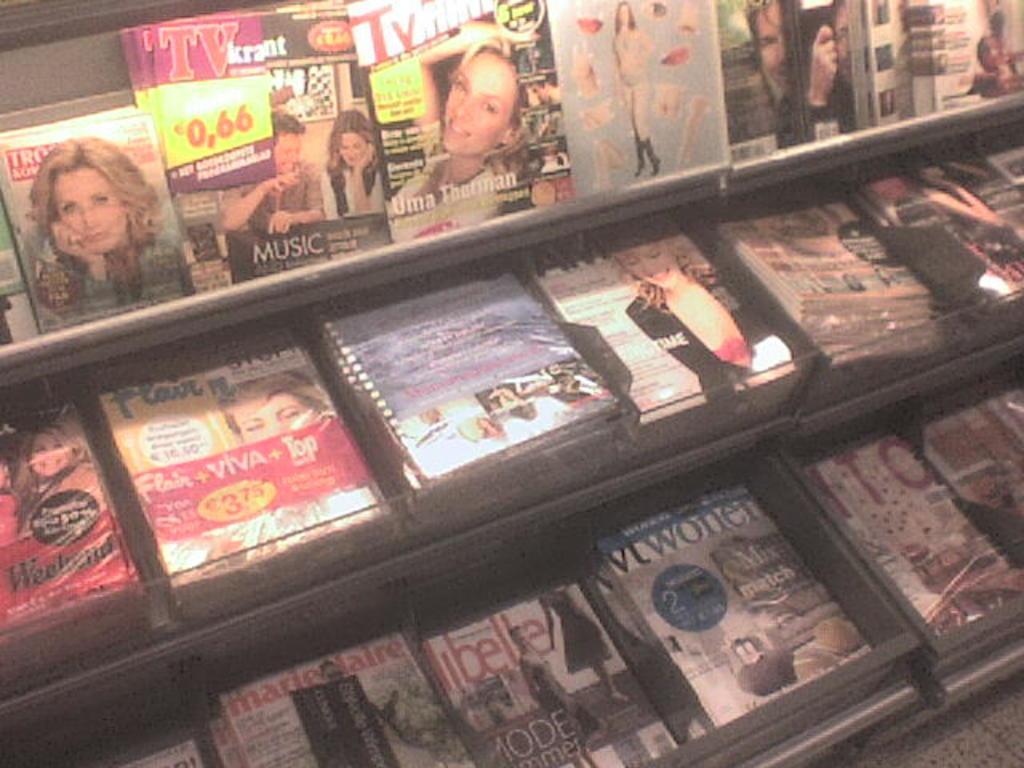In one or two sentences, can you explain what this image depicts? In this picture we can see shelves, there are some boxes present on these shelves. 